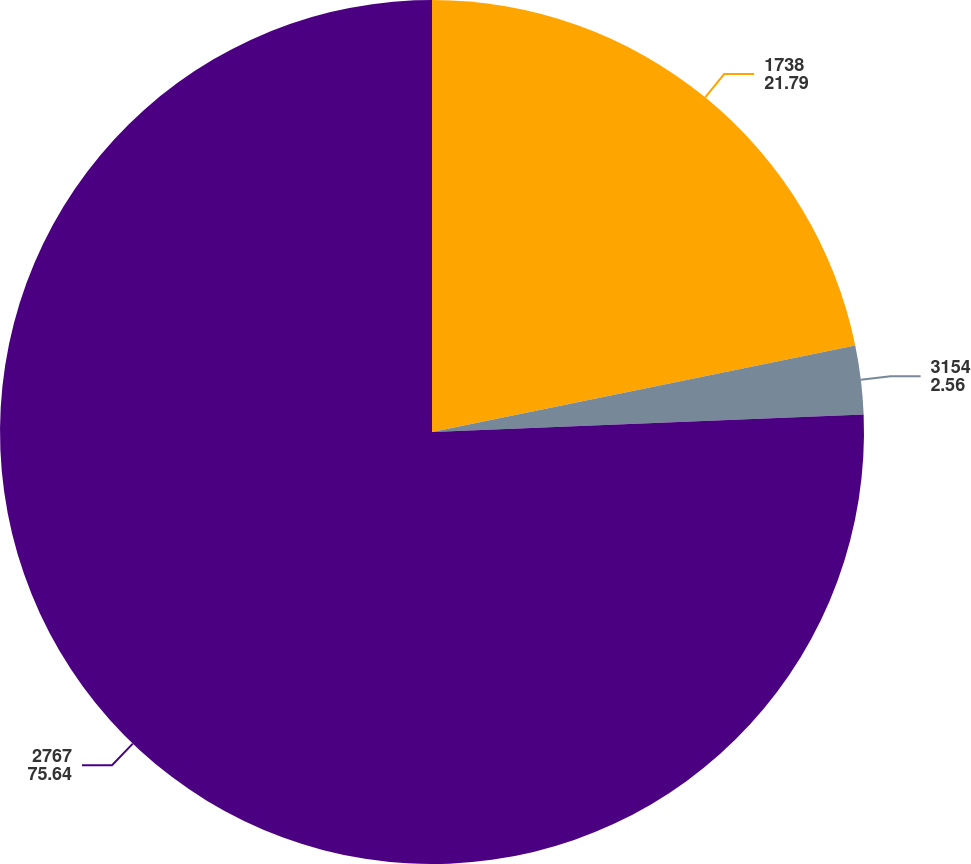Convert chart to OTSL. <chart><loc_0><loc_0><loc_500><loc_500><pie_chart><fcel>1738<fcel>3154<fcel>2767<nl><fcel>21.79%<fcel>2.56%<fcel>75.64%<nl></chart> 